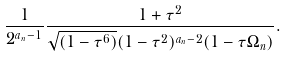Convert formula to latex. <formula><loc_0><loc_0><loc_500><loc_500>\frac { 1 } { 2 ^ { a _ { n } - 1 } } \frac { 1 + \tau ^ { 2 } } { \sqrt { ( 1 - \tau ^ { 6 } ) } ( 1 - \tau ^ { 2 } ) ^ { a _ { n } - 2 } ( 1 - \tau \Omega _ { n } ) } .</formula> 